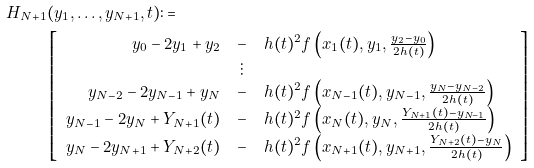Convert formula to latex. <formula><loc_0><loc_0><loc_500><loc_500>H _ { N + 1 } & ( y _ { 1 } , \dots , y _ { N + 1 } , t ) \colon = \\ & \left [ \begin{array} { r c l } y _ { 0 } - 2 y _ { 1 } + y _ { 2 } & - & h ( t ) ^ { 2 } f \left ( x _ { 1 } ( t ) , y _ { 1 } , \frac { y _ { 2 } - y _ { 0 } } { 2 h ( t ) } \right ) \\ & \vdots & \\ y _ { N - 2 } - 2 y _ { N - 1 } + y _ { N } & - & h ( t ) ^ { 2 } f \left ( x _ { N - 1 } ( t ) , y _ { N - 1 } , \frac { y _ { N } - y _ { N - 2 } } { 2 h ( t ) } \right ) \\ y _ { N - 1 } - 2 y _ { N } + Y _ { N + 1 } ( t ) & - & h ( t ) ^ { 2 } f \left ( x _ { N } ( t ) , y _ { N } , \frac { Y _ { N + 1 } ( t ) - y _ { N - 1 } } { 2 h ( t ) } \right ) \\ y _ { N } - 2 y _ { N + 1 } + Y _ { N + 2 } ( t ) & - & h ( t ) ^ { 2 } f \left ( x _ { N + 1 } ( t ) , y _ { N + 1 } , \frac { Y _ { N + 2 } ( t ) - y _ { N } } { 2 h ( t ) } \right ) \\ \end{array} \right ]</formula> 